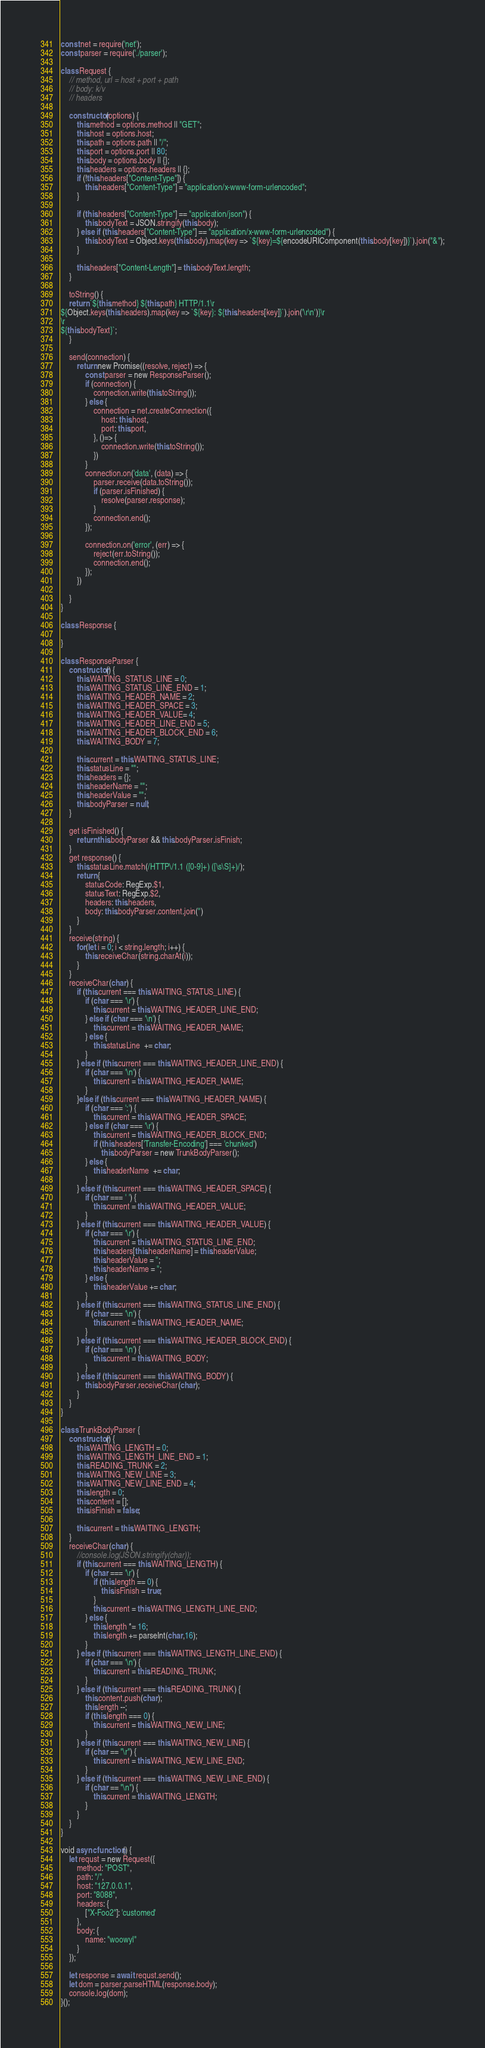Convert code to text. <code><loc_0><loc_0><loc_500><loc_500><_JavaScript_>const net = require('net');
const parser = require('./parser');

class Request {
    // method, url = host + port + path
    // body: k/v
    // headers

    constructor(options) {
        this.method = options.method || "GET";
        this.host = options.host;
        this.path = options.path || "/";
        this.port = options.port || 80;
        this.body = options.body || {};
        this.headers = options.headers || {};
        if (!this.headers["Content-Type"]) {
            this.headers["Content-Type"] = "application/x-www-form-urlencoded";
        }

        if (this.headers["Content-Type"] == "application/json") {
            this.bodyText = JSON.stringify(this.body);
        } else if (this.headers["Content-Type"] == "application/x-www-form-urlencoded") {
            this.bodyText = Object.keys(this.body).map(key => `${key}=${encodeURIComponent(this.body[key])}`).join("&");
        }

        this.headers["Content-Length"] = this.bodyText.length;
    }

    toString() {
    return `${this.method} ${this.path} HTTP/1.1\r
${Object.keys(this.headers).map(key => `${key}: ${this.headers[key]}`).join('\r\n')}\r
\r
${this.bodyText}`;
    }

    send(connection) {
        return new Promise((resolve, reject) => {
            const parser = new ResponseParser();
            if (connection) {
                connection.write(this.toString());
            } else {
                connection = net.createConnection({
                    host: this.host,
                    port: this.port,
                }, ()=> {
                    connection.write(this.toString());
                })
            }
            connection.on('data', (data) => {
                parser.receive(data.toString());
                if (parser.isFinished) {
                    resolve(parser.response);
                }
                connection.end();
            });

            connection.on('error', (err) => {
                reject(err.toString());
                connection.end();
            });
        })
        
    }
}

class Response {

}

class ResponseParser {
    constructor() {
        this.WAITING_STATUS_LINE = 0;
        this.WAITING_STATUS_LINE_END = 1;
        this.WAITING_HEADER_NAME = 2;
        this.WAITING_HEADER_SPACE = 3;
        this.WAITING_HEADER_VALUE= 4;
        this.WAITING_HEADER_LINE_END = 5;
        this.WAITING_HEADER_BLOCK_END = 6;
        this.WAITING_BODY = 7;

        this.current = this.WAITING_STATUS_LINE;
        this.statusLine = "";
        this.headers = {};
        this.headerName = "";
        this.headerValue = "";
        this.bodyParser = null;
    }

    get isFinished() {
        return this.bodyParser && this.bodyParser.isFinish;
    }
    get response() {
        this.statusLine.match(/HTTP\/1.1 ([0-9]+) ([\s\S]+)/);
        return {
            statusCode: RegExp.$1,
            statusText: RegExp.$2,
            headers: this.headers,
            body: this.bodyParser.content.join('')
        }
    }
    receive(string) {
        for(let i = 0; i < string.length; i++) {
            this.receiveChar(string.charAt(i));
        }
    }
    receiveChar(char) {
        if (this.current === this.WAITING_STATUS_LINE) {
            if (char === '\r') {
                this.current = this.WAITING_HEADER_LINE_END;
            } else if (char === '\n') {
                this.current = this.WAITING_HEADER_NAME;
            } else {
                this.statusLine  += char;
            }
        } else if (this.current === this.WAITING_HEADER_LINE_END) {
            if (char === '\n') {
                this.current = this.WAITING_HEADER_NAME;
            } 
        }else if (this.current === this.WAITING_HEADER_NAME) {
            if (char === ':') {
                this.current = this.WAITING_HEADER_SPACE;
            } else if (char === '\r') {
                this.current = this.WAITING_HEADER_BLOCK_END;
                if (this.headers['Transfer-Encoding'] === 'chunked')
                    this.bodyParser = new TrunkBodyParser();
            } else {
                this.headerName  += char;
            }
        } else if (this.current === this.WAITING_HEADER_SPACE) {
            if (char === ' ') {
                this.current = this.WAITING_HEADER_VALUE;
            }
        } else if (this.current === this.WAITING_HEADER_VALUE) {
            if (char === '\r') {
                this.current = this.WAITING_STATUS_LINE_END;
                this.headers[this.headerName] = this.headerValue;
                this.headerValue = '';
                this.headerName = '';
            } else {
                this.headerValue += char;
            }
        } else if (this.current === this.WAITING_STATUS_LINE_END) {
            if (char === '\n') {
                this.current = this.WAITING_HEADER_NAME;
            }
        } else if (this.current === this.WAITING_HEADER_BLOCK_END) {
            if (char === '\n') {
                this.current = this.WAITING_BODY;
            }
        } else if (this.current === this.WAITING_BODY) {
            this.bodyParser.receiveChar(char);
        }
    }
}

class TrunkBodyParser {
    constructor() {
        this.WAITING_LENGTH = 0;
        this.WAITING_LENGTH_LINE_END = 1;
        this.READING_TRUNK = 2;
        this.WAITING_NEW_LINE = 3;
        this.WAITING_NEW_LINE_END = 4;
        this.length = 0;
        this.content = [];
        this.isFinish = false;

        this.current = this.WAITING_LENGTH;
    }
    receiveChar(char) {
        //console.log(JSON.stringify(char));
        if (this.current === this.WAITING_LENGTH) {
            if (char === '\r') {
                if (this.length == 0) {
                    this.isFinish = true;
                }
                this.current = this.WAITING_LENGTH_LINE_END;
            } else {
                this.length *= 16;
                this.length += parseInt(char,16);
            }
        } else if (this.current === this.WAITING_LENGTH_LINE_END) {
            if (char === '\n') {
                this.current = this.READING_TRUNK;
            }
        } else if (this.current === this.READING_TRUNK) {
            this.content.push(char);
            this.length --;
            if (this.length === 0) {
                this.current = this.WAITING_NEW_LINE;
            }
        } else if (this.current === this.WAITING_NEW_LINE) {
            if (char == "\r") {
                this.current = this.WAITING_NEW_LINE_END;
            }
        } else if (this.current === this.WAITING_NEW_LINE_END) {
            if (char == "\n") {
                this.current = this.WAITING_LENGTH;
            }
        }
    }
}

void async function() {
    let requst = new Request({
        method: "POST",
        path: "/",
        host: "127.0.0.1",
        port: "8088",
        headers: {
            ["X-Foo2"]: 'customed'
        },
        body: {
            name: "woowyl"
        }
    });
    
    let response = await requst.send();
    let dom = parser.parseHTML(response.body);
    console.log(dom);
}();
</code> 